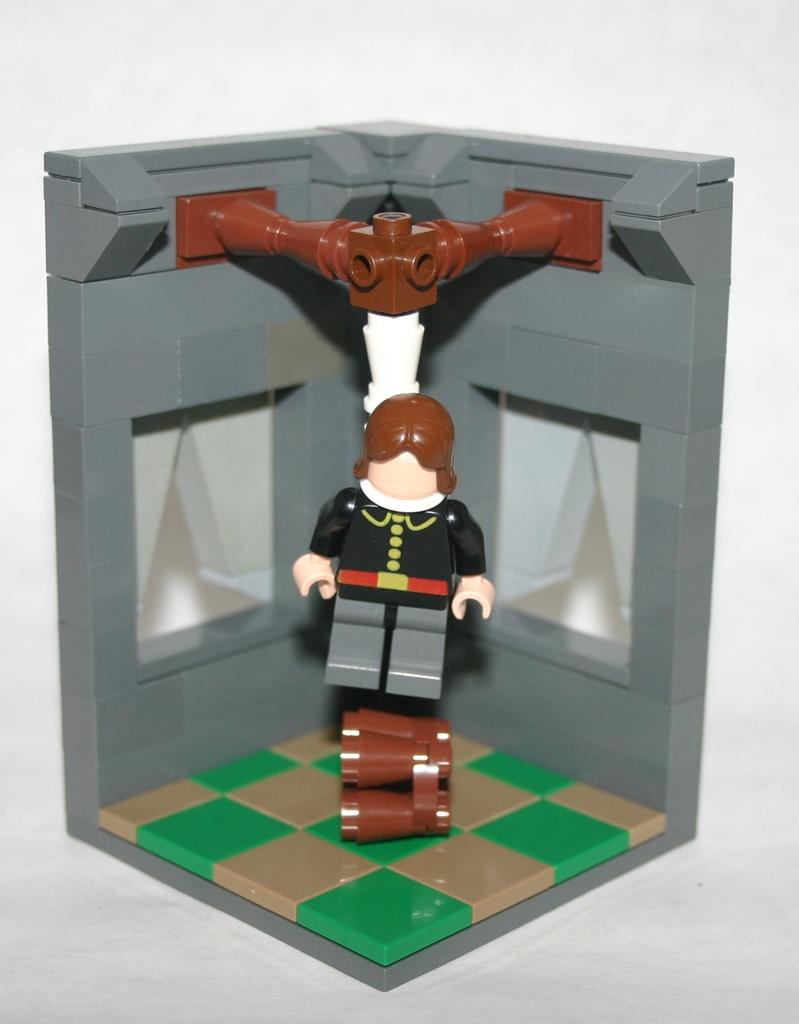What objects are present in the image? There are toys in the image. What color is the background of the image? The background of the image is white. Can you describe the setting of the image? The image may have been taken in a room, based on the white background. How many people are resting in the image? There are no people present in the image, so it is not possible to determine how many are resting. 